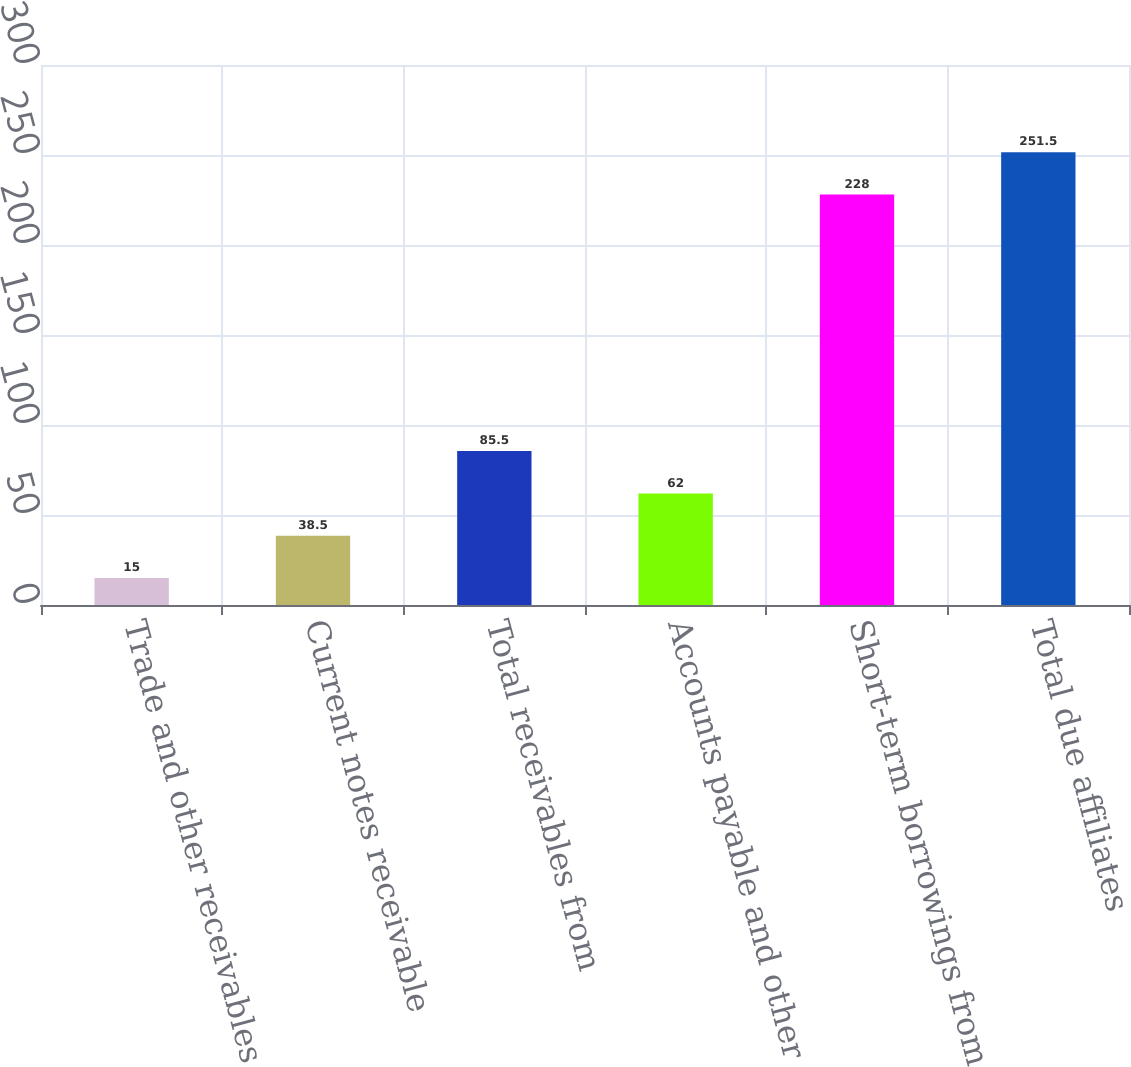Convert chart. <chart><loc_0><loc_0><loc_500><loc_500><bar_chart><fcel>Trade and other receivables<fcel>Current notes receivable<fcel>Total receivables from<fcel>Accounts payable and other<fcel>Short-term borrowings from<fcel>Total due affiliates<nl><fcel>15<fcel>38.5<fcel>85.5<fcel>62<fcel>228<fcel>251.5<nl></chart> 